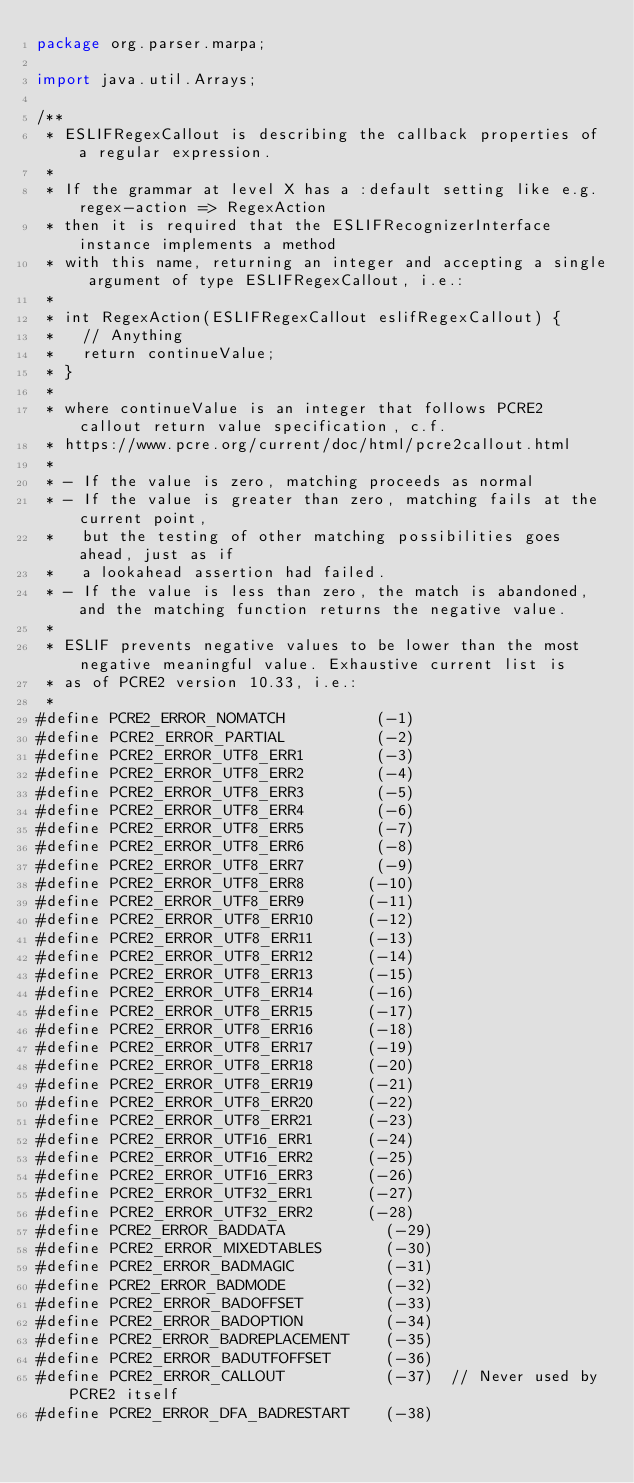Convert code to text. <code><loc_0><loc_0><loc_500><loc_500><_Java_>package org.parser.marpa;

import java.util.Arrays;

/**
 * ESLIFRegexCallout is describing the callback properties of a regular expression.
 * 
 * If the grammar at level X has a :default setting like e.g. regex-action => RegexAction
 * then it is required that the ESLIFRecognizerInterface instance implements a method
 * with this name, returning an integer and accepting a single argument of type ESLIFRegexCallout, i.e.:
 * 
 * int RegexAction(ESLIFRegexCallout eslifRegexCallout) {
 *   // Anything
 *   return continueValue;
 * }
 * 
 * where continueValue is an integer that follows PCRE2 callout return value specification, c.f.
 * https://www.pcre.org/current/doc/html/pcre2callout.html
 * 
 * - If the value is zero, matching proceeds as normal
 * - If the value is greater than zero, matching fails at the current point,
 *   but the testing of other matching possibilities goes ahead, just as if
 *   a lookahead assertion had failed.
 * - If the value is less than zero, the match is abandoned, and the matching function returns the negative value. 
 *
 * ESLIF prevents negative values to be lower than the most negative meaningful value. Exhaustive current list is
 * as of PCRE2 version 10.33, i.e.:
 * 
#define PCRE2_ERROR_NOMATCH          (-1)
#define PCRE2_ERROR_PARTIAL          (-2)
#define PCRE2_ERROR_UTF8_ERR1        (-3)
#define PCRE2_ERROR_UTF8_ERR2        (-4)
#define PCRE2_ERROR_UTF8_ERR3        (-5)
#define PCRE2_ERROR_UTF8_ERR4        (-6)
#define PCRE2_ERROR_UTF8_ERR5        (-7)
#define PCRE2_ERROR_UTF8_ERR6        (-8)
#define PCRE2_ERROR_UTF8_ERR7        (-9)
#define PCRE2_ERROR_UTF8_ERR8       (-10)
#define PCRE2_ERROR_UTF8_ERR9       (-11)
#define PCRE2_ERROR_UTF8_ERR10      (-12)
#define PCRE2_ERROR_UTF8_ERR11      (-13)
#define PCRE2_ERROR_UTF8_ERR12      (-14)
#define PCRE2_ERROR_UTF8_ERR13      (-15)
#define PCRE2_ERROR_UTF8_ERR14      (-16)
#define PCRE2_ERROR_UTF8_ERR15      (-17)
#define PCRE2_ERROR_UTF8_ERR16      (-18)
#define PCRE2_ERROR_UTF8_ERR17      (-19)
#define PCRE2_ERROR_UTF8_ERR18      (-20)
#define PCRE2_ERROR_UTF8_ERR19      (-21)
#define PCRE2_ERROR_UTF8_ERR20      (-22)
#define PCRE2_ERROR_UTF8_ERR21      (-23)
#define PCRE2_ERROR_UTF16_ERR1      (-24)
#define PCRE2_ERROR_UTF16_ERR2      (-25)
#define PCRE2_ERROR_UTF16_ERR3      (-26)
#define PCRE2_ERROR_UTF32_ERR1      (-27)
#define PCRE2_ERROR_UTF32_ERR2      (-28)
#define PCRE2_ERROR_BADDATA           (-29)
#define PCRE2_ERROR_MIXEDTABLES       (-30)
#define PCRE2_ERROR_BADMAGIC          (-31)
#define PCRE2_ERROR_BADMODE           (-32)
#define PCRE2_ERROR_BADOFFSET         (-33)
#define PCRE2_ERROR_BADOPTION         (-34)
#define PCRE2_ERROR_BADREPLACEMENT    (-35)
#define PCRE2_ERROR_BADUTFOFFSET      (-36)
#define PCRE2_ERROR_CALLOUT           (-37)  // Never used by PCRE2 itself
#define PCRE2_ERROR_DFA_BADRESTART    (-38)</code> 